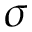<formula> <loc_0><loc_0><loc_500><loc_500>\sigma</formula> 